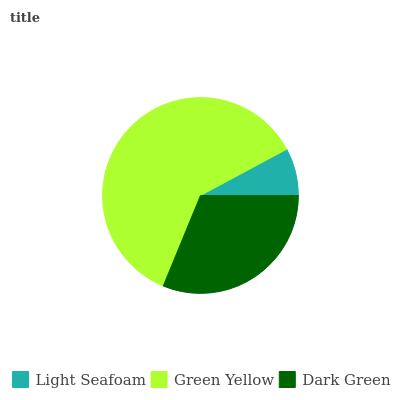Is Light Seafoam the minimum?
Answer yes or no. Yes. Is Green Yellow the maximum?
Answer yes or no. Yes. Is Dark Green the minimum?
Answer yes or no. No. Is Dark Green the maximum?
Answer yes or no. No. Is Green Yellow greater than Dark Green?
Answer yes or no. Yes. Is Dark Green less than Green Yellow?
Answer yes or no. Yes. Is Dark Green greater than Green Yellow?
Answer yes or no. No. Is Green Yellow less than Dark Green?
Answer yes or no. No. Is Dark Green the high median?
Answer yes or no. Yes. Is Dark Green the low median?
Answer yes or no. Yes. Is Light Seafoam the high median?
Answer yes or no. No. Is Light Seafoam the low median?
Answer yes or no. No. 